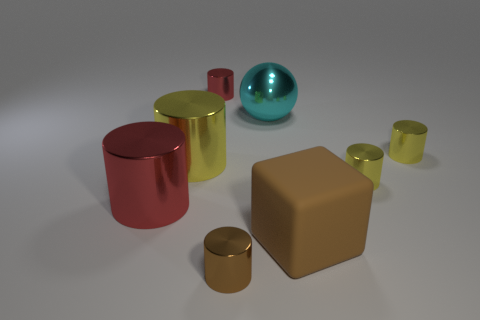How many yellow cylinders must be subtracted to get 1 yellow cylinders? 2 Subtract all purple cubes. How many yellow cylinders are left? 3 Subtract all red cylinders. How many cylinders are left? 4 Subtract all tiny red metallic cylinders. How many cylinders are left? 5 Subtract all gray cylinders. Subtract all cyan spheres. How many cylinders are left? 6 Add 2 cyan objects. How many objects exist? 10 Subtract all spheres. How many objects are left? 7 Add 7 large brown metallic spheres. How many large brown metallic spheres exist? 7 Subtract 0 green blocks. How many objects are left? 8 Subtract all big cylinders. Subtract all red cylinders. How many objects are left? 4 